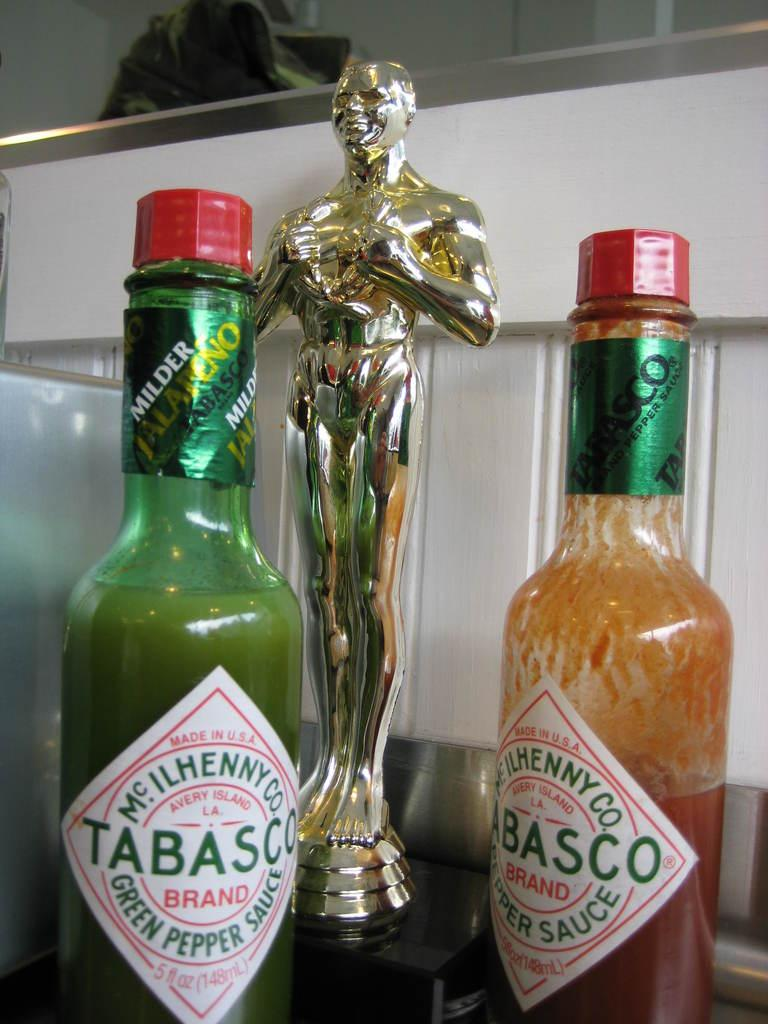<image>
Share a concise interpretation of the image provided. Two Tabasco bottles sit next to each other; one in green and the other red. 